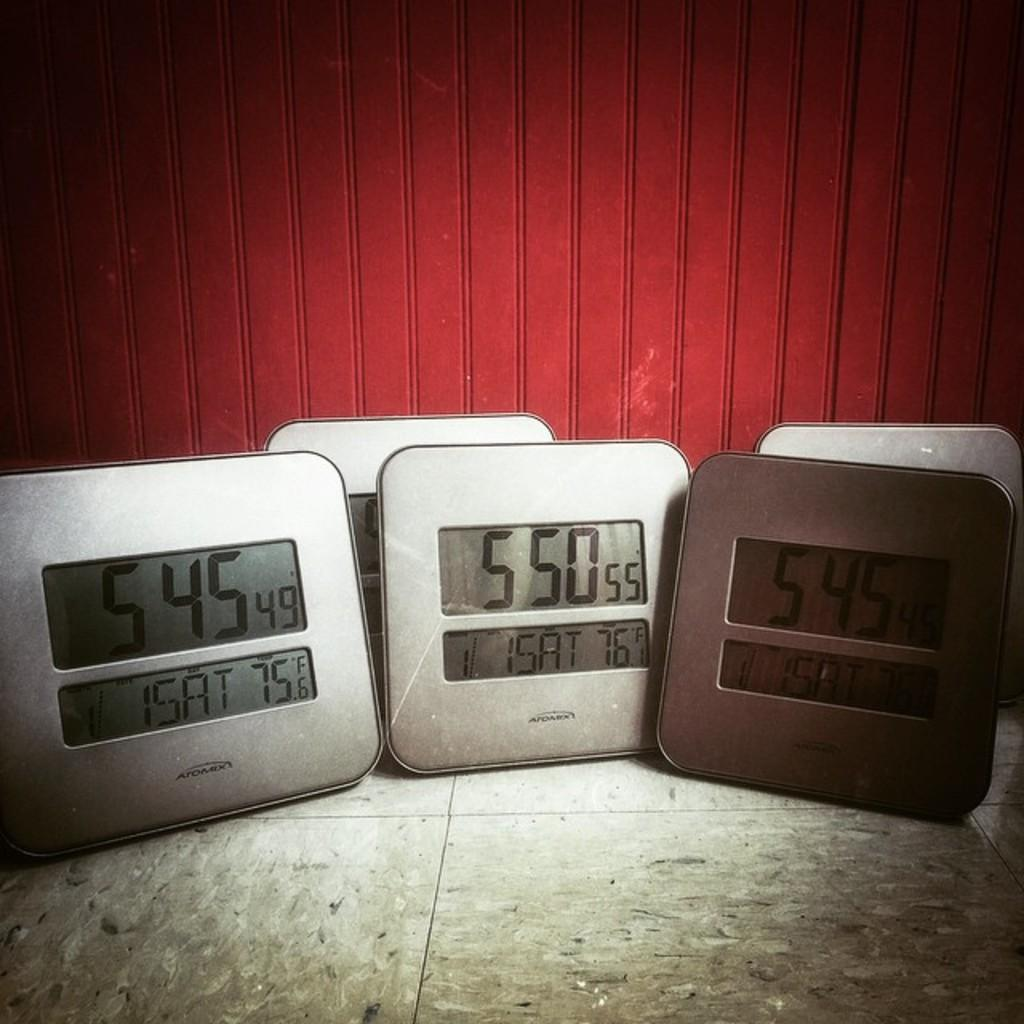<image>
Create a compact narrative representing the image presented. three scales with the numbers 545 550 and 545 on them 